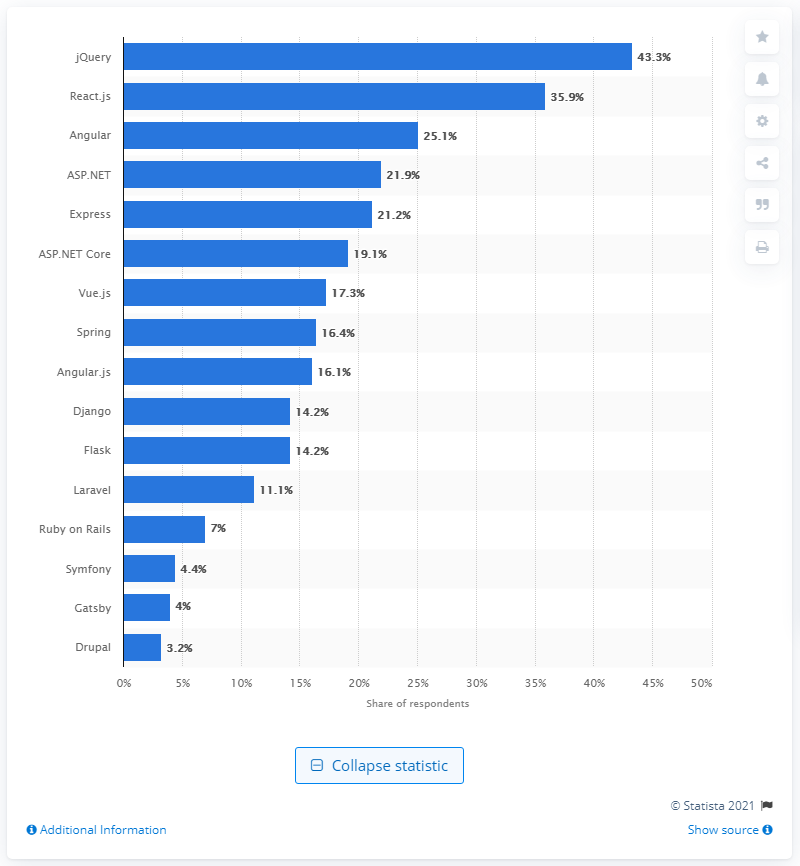jQuery has been losing ground to React.js and what other framework?
 Angular 